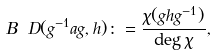Convert formula to latex. <formula><loc_0><loc_0><loc_500><loc_500>B _ { \ } D ( g ^ { - 1 } a g , h ) \colon = \frac { \chi ( g h g ^ { - 1 } ) } { \deg \chi } ,</formula> 